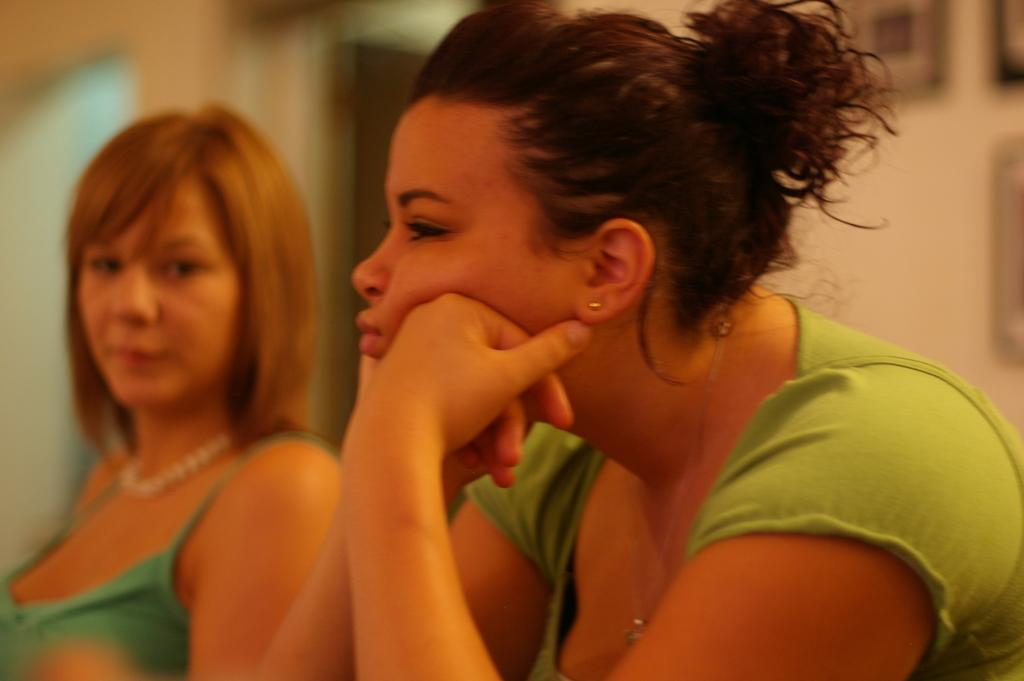Who is the main subject in the foreground of the picture? There is a woman in the foreground of the picture. Can you describe the other person in the image? There is another person on the left side of the picture. What can be observed about the background of the image? The background of the image is blurred. What type of spoon can be seen in the woman's hand in the image? There is no spoon visible in the woman's hand in the image. Can you describe the crate that the woman is sitting on in the image? There is no crate present in the image. 